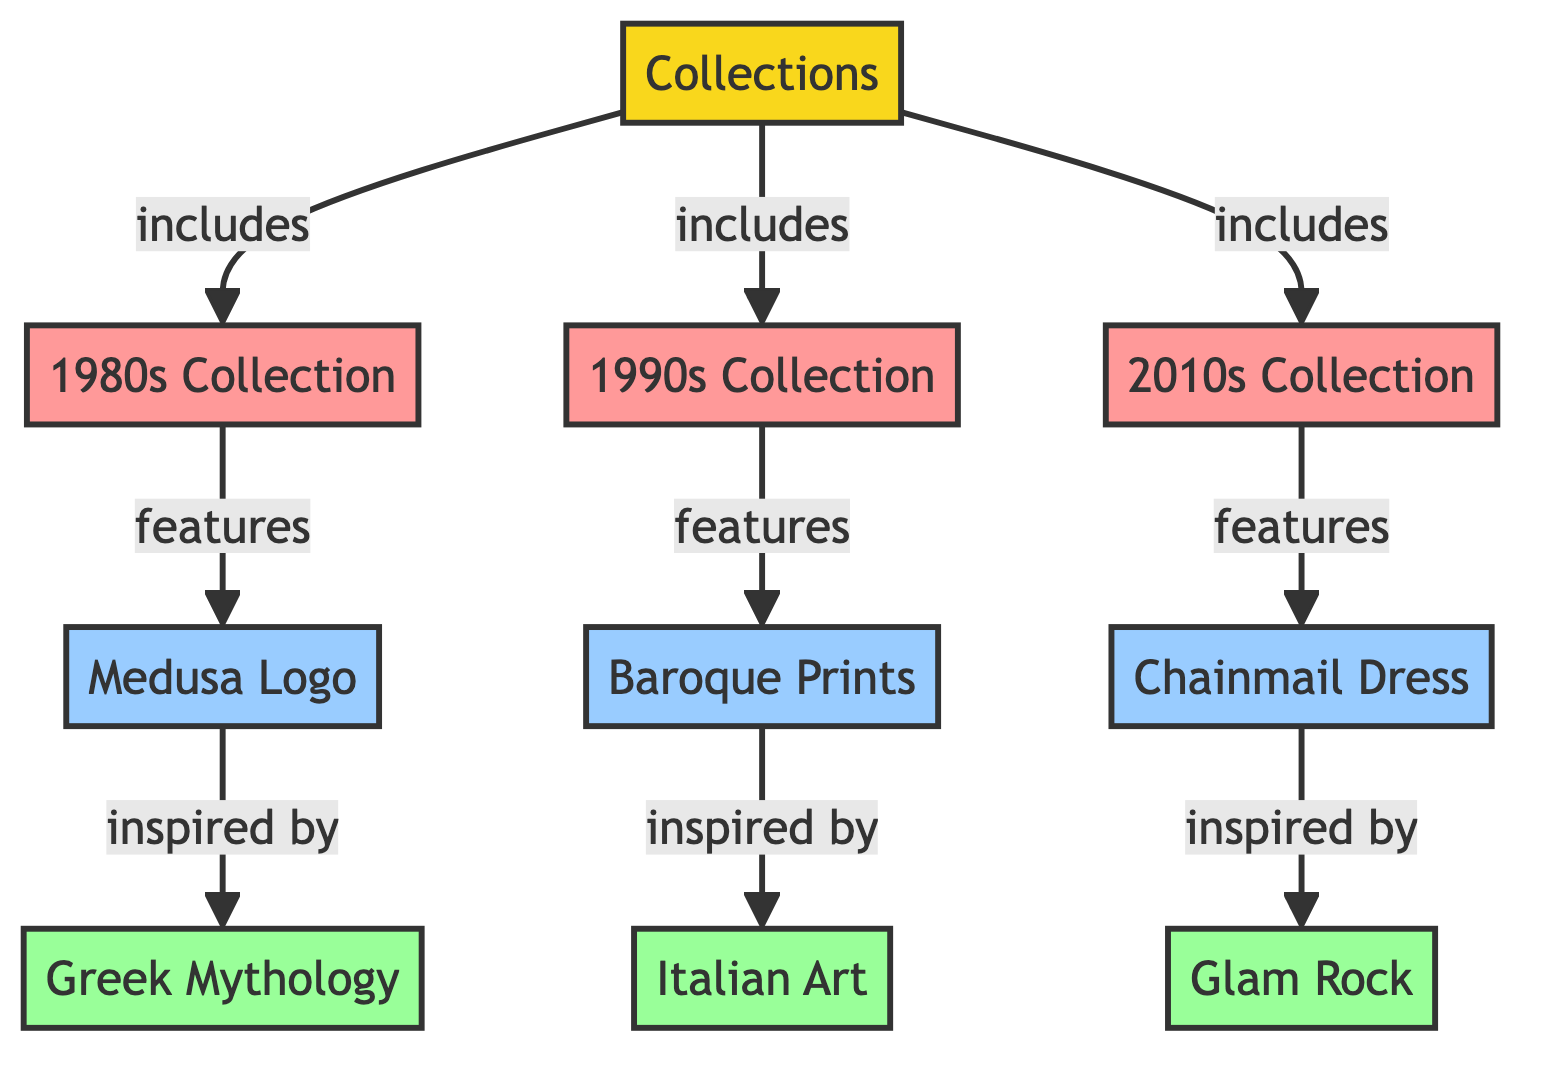What are the three main decades represented in Versace's iconic collections? The diagram showcases three decades: 1980s, 1990s, and 2010s. Each decade is connected to a collection node, which indicates the major collections featured.
Answer: 1980s, 1990s, 2010s How many features are linked to the 1990s Collection? The 1990s Collection node directly connects to one feature node labeled Baroque Prints, indicating that there is only one feature listed for this collection.
Answer: 1 What inspired the Medusa Logo from the 1980s Collection? The diagram shows that the Medusa Logo feature is inspired by Greek Mythology, directly linking these two nodes through the relationship indicated in the flowchart.
Answer: Greek Mythology Which iconic feature is associated with the 2010s Collection? As per the diagram, the 2010s Collection is linked to the Chainmail Dress, representing the signature feature of this particular collection.
Answer: Chainmail Dress What is the relationship between Baroque Prints and Italian Art? The link from the Baroque Prints feature to Italian Art inspiration indicates that the feature of Baroque Prints is influenced by Italian Art, establishing a direct connection between these components.
Answer: inspired by How many inspirations are listed in total for all the collections shown? The diagram includes three inspiration nodes: Greek Mythology, Italian Art, and Glam Rock, thus adding up to a total of three inspirations throughout the collections represented.
Answer: 3 Which collection features Glam Rock as an inspiration? The diagram indicates that Glam Rock is tied to the 2010s Collection as its source of inspiration, making it directly associated with this particular time period in Versace's design work.
Answer: 2010s Collection What is the main feature linked to the 1980s Collection? According to the diagram, the main feature of the 1980s Collection is represented as the Medusa Logo, directly indicating the iconographic element of this collection.
Answer: Medusa Logo Which decade does the Chainmail Dress belong to? The flowchart specifically indicates that the Chainmail Dress is a feature of the 2010s Collection, thus linking it to that particular decade in Vector's timeline.
Answer: 2010s Collection 